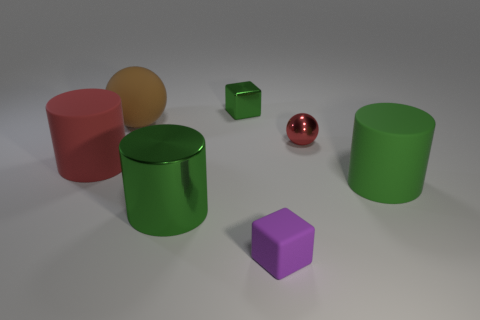Can you describe the textures of the various objects in the scene? Certainly! The objects in the scene display a variety of textures. The red sphere has a glossy, reflective surface, hinting at a smooth, perhaps metallic texture. The green cylinder and cube have a matte finish suggesting a more diffuse, possibly plastic texture. The purple cube appears similarly matte, which might imply a non-reflective material. The orange sphere has a muted reflection, indicative of a slightly smoother surface than the green and purple objects, but not as perfect as the red sphere's. The contrast in textures adds visual interest to the scene. 